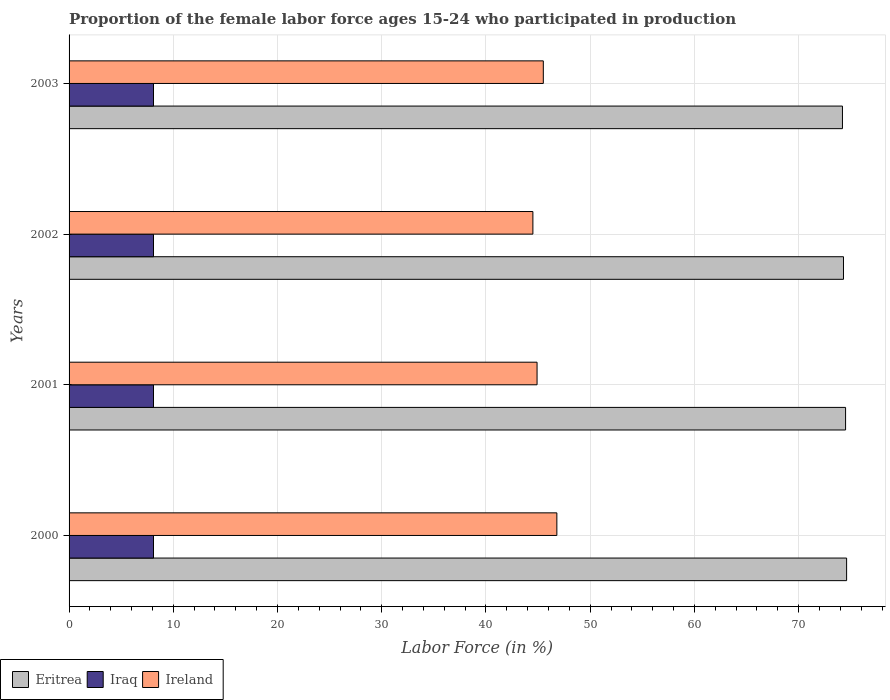How many groups of bars are there?
Provide a succinct answer. 4. Are the number of bars per tick equal to the number of legend labels?
Make the answer very short. Yes. Are the number of bars on each tick of the Y-axis equal?
Your answer should be compact. Yes. In how many cases, is the number of bars for a given year not equal to the number of legend labels?
Your answer should be compact. 0. What is the proportion of the female labor force who participated in production in Ireland in 2003?
Provide a succinct answer. 45.5. Across all years, what is the maximum proportion of the female labor force who participated in production in Ireland?
Provide a succinct answer. 46.8. Across all years, what is the minimum proportion of the female labor force who participated in production in Eritrea?
Ensure brevity in your answer.  74.2. In which year was the proportion of the female labor force who participated in production in Eritrea maximum?
Your answer should be compact. 2000. In which year was the proportion of the female labor force who participated in production in Eritrea minimum?
Your answer should be very brief. 2003. What is the total proportion of the female labor force who participated in production in Eritrea in the graph?
Your response must be concise. 297.6. What is the difference between the proportion of the female labor force who participated in production in Ireland in 2001 and that in 2002?
Make the answer very short. 0.4. What is the difference between the proportion of the female labor force who participated in production in Eritrea in 2000 and the proportion of the female labor force who participated in production in Iraq in 2001?
Make the answer very short. 66.5. What is the average proportion of the female labor force who participated in production in Ireland per year?
Your answer should be compact. 45.43. In the year 2000, what is the difference between the proportion of the female labor force who participated in production in Eritrea and proportion of the female labor force who participated in production in Iraq?
Your response must be concise. 66.5. What is the ratio of the proportion of the female labor force who participated in production in Ireland in 2000 to that in 2001?
Ensure brevity in your answer.  1.04. Is the difference between the proportion of the female labor force who participated in production in Eritrea in 2002 and 2003 greater than the difference between the proportion of the female labor force who participated in production in Iraq in 2002 and 2003?
Your answer should be very brief. Yes. What is the difference between the highest and the second highest proportion of the female labor force who participated in production in Eritrea?
Make the answer very short. 0.1. What is the difference between the highest and the lowest proportion of the female labor force who participated in production in Ireland?
Provide a succinct answer. 2.3. In how many years, is the proportion of the female labor force who participated in production in Iraq greater than the average proportion of the female labor force who participated in production in Iraq taken over all years?
Your answer should be very brief. 0. What does the 2nd bar from the top in 2002 represents?
Your answer should be compact. Iraq. What does the 1st bar from the bottom in 2000 represents?
Offer a terse response. Eritrea. Is it the case that in every year, the sum of the proportion of the female labor force who participated in production in Eritrea and proportion of the female labor force who participated in production in Iraq is greater than the proportion of the female labor force who participated in production in Ireland?
Offer a terse response. Yes. What is the difference between two consecutive major ticks on the X-axis?
Give a very brief answer. 10. Are the values on the major ticks of X-axis written in scientific E-notation?
Your answer should be very brief. No. Does the graph contain any zero values?
Provide a succinct answer. No. Does the graph contain grids?
Offer a terse response. Yes. Where does the legend appear in the graph?
Make the answer very short. Bottom left. What is the title of the graph?
Offer a very short reply. Proportion of the female labor force ages 15-24 who participated in production. What is the label or title of the X-axis?
Provide a short and direct response. Labor Force (in %). What is the label or title of the Y-axis?
Give a very brief answer. Years. What is the Labor Force (in %) of Eritrea in 2000?
Offer a terse response. 74.6. What is the Labor Force (in %) of Iraq in 2000?
Provide a succinct answer. 8.1. What is the Labor Force (in %) in Ireland in 2000?
Make the answer very short. 46.8. What is the Labor Force (in %) of Eritrea in 2001?
Your answer should be very brief. 74.5. What is the Labor Force (in %) in Iraq in 2001?
Provide a succinct answer. 8.1. What is the Labor Force (in %) in Ireland in 2001?
Your answer should be compact. 44.9. What is the Labor Force (in %) of Eritrea in 2002?
Offer a very short reply. 74.3. What is the Labor Force (in %) in Iraq in 2002?
Ensure brevity in your answer.  8.1. What is the Labor Force (in %) of Ireland in 2002?
Your response must be concise. 44.5. What is the Labor Force (in %) of Eritrea in 2003?
Your answer should be very brief. 74.2. What is the Labor Force (in %) in Iraq in 2003?
Your response must be concise. 8.1. What is the Labor Force (in %) of Ireland in 2003?
Keep it short and to the point. 45.5. Across all years, what is the maximum Labor Force (in %) of Eritrea?
Offer a very short reply. 74.6. Across all years, what is the maximum Labor Force (in %) of Iraq?
Your answer should be very brief. 8.1. Across all years, what is the maximum Labor Force (in %) in Ireland?
Offer a terse response. 46.8. Across all years, what is the minimum Labor Force (in %) of Eritrea?
Provide a succinct answer. 74.2. Across all years, what is the minimum Labor Force (in %) of Iraq?
Provide a short and direct response. 8.1. Across all years, what is the minimum Labor Force (in %) of Ireland?
Offer a terse response. 44.5. What is the total Labor Force (in %) in Eritrea in the graph?
Your response must be concise. 297.6. What is the total Labor Force (in %) in Iraq in the graph?
Offer a very short reply. 32.4. What is the total Labor Force (in %) of Ireland in the graph?
Provide a short and direct response. 181.7. What is the difference between the Labor Force (in %) of Eritrea in 2000 and that in 2001?
Ensure brevity in your answer.  0.1. What is the difference between the Labor Force (in %) in Ireland in 2000 and that in 2001?
Offer a very short reply. 1.9. What is the difference between the Labor Force (in %) of Ireland in 2000 and that in 2002?
Give a very brief answer. 2.3. What is the difference between the Labor Force (in %) in Ireland in 2001 and that in 2002?
Give a very brief answer. 0.4. What is the difference between the Labor Force (in %) in Ireland in 2001 and that in 2003?
Your answer should be very brief. -0.6. What is the difference between the Labor Force (in %) of Iraq in 2002 and that in 2003?
Offer a very short reply. 0. What is the difference between the Labor Force (in %) in Ireland in 2002 and that in 2003?
Offer a terse response. -1. What is the difference between the Labor Force (in %) of Eritrea in 2000 and the Labor Force (in %) of Iraq in 2001?
Your response must be concise. 66.5. What is the difference between the Labor Force (in %) in Eritrea in 2000 and the Labor Force (in %) in Ireland in 2001?
Your response must be concise. 29.7. What is the difference between the Labor Force (in %) of Iraq in 2000 and the Labor Force (in %) of Ireland in 2001?
Provide a succinct answer. -36.8. What is the difference between the Labor Force (in %) of Eritrea in 2000 and the Labor Force (in %) of Iraq in 2002?
Give a very brief answer. 66.5. What is the difference between the Labor Force (in %) of Eritrea in 2000 and the Labor Force (in %) of Ireland in 2002?
Offer a terse response. 30.1. What is the difference between the Labor Force (in %) of Iraq in 2000 and the Labor Force (in %) of Ireland in 2002?
Provide a succinct answer. -36.4. What is the difference between the Labor Force (in %) of Eritrea in 2000 and the Labor Force (in %) of Iraq in 2003?
Your answer should be very brief. 66.5. What is the difference between the Labor Force (in %) in Eritrea in 2000 and the Labor Force (in %) in Ireland in 2003?
Keep it short and to the point. 29.1. What is the difference between the Labor Force (in %) of Iraq in 2000 and the Labor Force (in %) of Ireland in 2003?
Provide a short and direct response. -37.4. What is the difference between the Labor Force (in %) in Eritrea in 2001 and the Labor Force (in %) in Iraq in 2002?
Keep it short and to the point. 66.4. What is the difference between the Labor Force (in %) in Eritrea in 2001 and the Labor Force (in %) in Ireland in 2002?
Your answer should be compact. 30. What is the difference between the Labor Force (in %) of Iraq in 2001 and the Labor Force (in %) of Ireland in 2002?
Give a very brief answer. -36.4. What is the difference between the Labor Force (in %) in Eritrea in 2001 and the Labor Force (in %) in Iraq in 2003?
Your answer should be very brief. 66.4. What is the difference between the Labor Force (in %) of Eritrea in 2001 and the Labor Force (in %) of Ireland in 2003?
Your response must be concise. 29. What is the difference between the Labor Force (in %) of Iraq in 2001 and the Labor Force (in %) of Ireland in 2003?
Your answer should be very brief. -37.4. What is the difference between the Labor Force (in %) in Eritrea in 2002 and the Labor Force (in %) in Iraq in 2003?
Offer a terse response. 66.2. What is the difference between the Labor Force (in %) of Eritrea in 2002 and the Labor Force (in %) of Ireland in 2003?
Make the answer very short. 28.8. What is the difference between the Labor Force (in %) of Iraq in 2002 and the Labor Force (in %) of Ireland in 2003?
Ensure brevity in your answer.  -37.4. What is the average Labor Force (in %) of Eritrea per year?
Offer a very short reply. 74.4. What is the average Labor Force (in %) in Iraq per year?
Provide a short and direct response. 8.1. What is the average Labor Force (in %) in Ireland per year?
Offer a very short reply. 45.42. In the year 2000, what is the difference between the Labor Force (in %) of Eritrea and Labor Force (in %) of Iraq?
Give a very brief answer. 66.5. In the year 2000, what is the difference between the Labor Force (in %) in Eritrea and Labor Force (in %) in Ireland?
Offer a very short reply. 27.8. In the year 2000, what is the difference between the Labor Force (in %) in Iraq and Labor Force (in %) in Ireland?
Ensure brevity in your answer.  -38.7. In the year 2001, what is the difference between the Labor Force (in %) in Eritrea and Labor Force (in %) in Iraq?
Offer a terse response. 66.4. In the year 2001, what is the difference between the Labor Force (in %) of Eritrea and Labor Force (in %) of Ireland?
Offer a very short reply. 29.6. In the year 2001, what is the difference between the Labor Force (in %) of Iraq and Labor Force (in %) of Ireland?
Offer a very short reply. -36.8. In the year 2002, what is the difference between the Labor Force (in %) in Eritrea and Labor Force (in %) in Iraq?
Offer a very short reply. 66.2. In the year 2002, what is the difference between the Labor Force (in %) of Eritrea and Labor Force (in %) of Ireland?
Ensure brevity in your answer.  29.8. In the year 2002, what is the difference between the Labor Force (in %) of Iraq and Labor Force (in %) of Ireland?
Keep it short and to the point. -36.4. In the year 2003, what is the difference between the Labor Force (in %) in Eritrea and Labor Force (in %) in Iraq?
Offer a very short reply. 66.1. In the year 2003, what is the difference between the Labor Force (in %) in Eritrea and Labor Force (in %) in Ireland?
Offer a very short reply. 28.7. In the year 2003, what is the difference between the Labor Force (in %) in Iraq and Labor Force (in %) in Ireland?
Your response must be concise. -37.4. What is the ratio of the Labor Force (in %) in Ireland in 2000 to that in 2001?
Keep it short and to the point. 1.04. What is the ratio of the Labor Force (in %) in Eritrea in 2000 to that in 2002?
Provide a succinct answer. 1. What is the ratio of the Labor Force (in %) of Ireland in 2000 to that in 2002?
Your answer should be compact. 1.05. What is the ratio of the Labor Force (in %) in Eritrea in 2000 to that in 2003?
Your response must be concise. 1.01. What is the ratio of the Labor Force (in %) in Iraq in 2000 to that in 2003?
Give a very brief answer. 1. What is the ratio of the Labor Force (in %) of Ireland in 2000 to that in 2003?
Provide a succinct answer. 1.03. What is the ratio of the Labor Force (in %) in Eritrea in 2001 to that in 2002?
Ensure brevity in your answer.  1. What is the ratio of the Labor Force (in %) in Iraq in 2001 to that in 2002?
Make the answer very short. 1. What is the ratio of the Labor Force (in %) in Eritrea in 2002 to that in 2003?
Ensure brevity in your answer.  1. What is the ratio of the Labor Force (in %) in Ireland in 2002 to that in 2003?
Make the answer very short. 0.98. What is the difference between the highest and the second highest Labor Force (in %) in Eritrea?
Offer a terse response. 0.1. What is the difference between the highest and the second highest Labor Force (in %) in Iraq?
Provide a short and direct response. 0. What is the difference between the highest and the lowest Labor Force (in %) of Eritrea?
Offer a very short reply. 0.4. What is the difference between the highest and the lowest Labor Force (in %) of Iraq?
Offer a terse response. 0. 